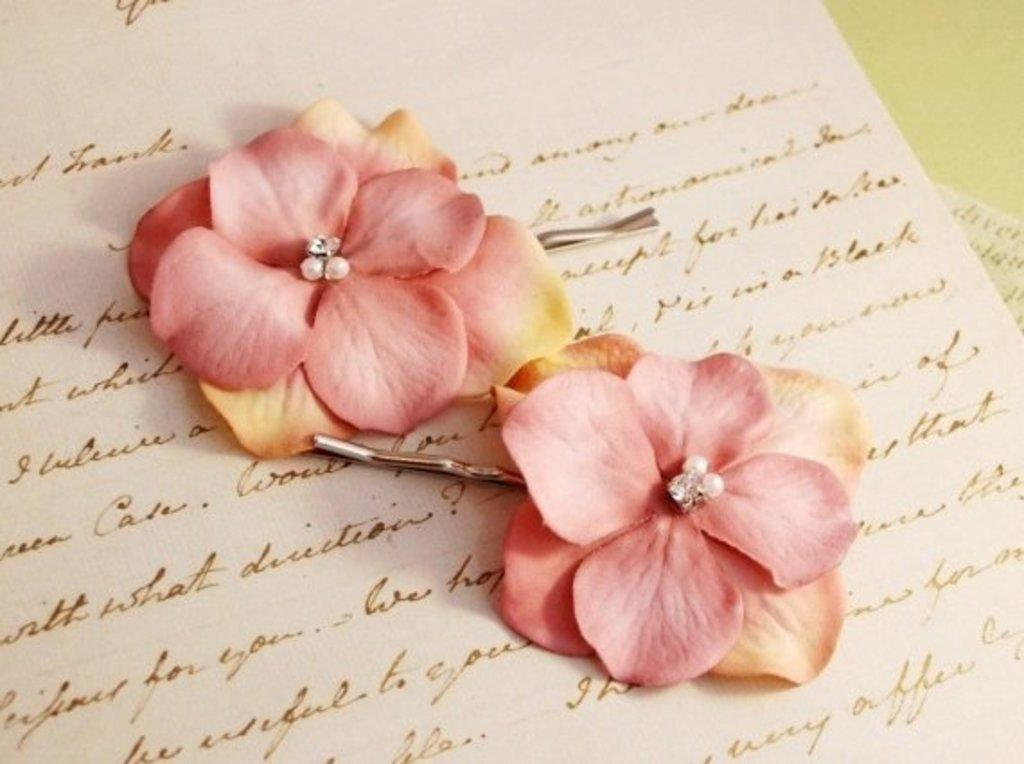What objects are present in the image? There are flower clips in the image. Where are the flower clips placed? The flower clips are kept on a paper. What type of society is depicted in the image? There is no society depicted in the image; it only features flower clips on a paper. 